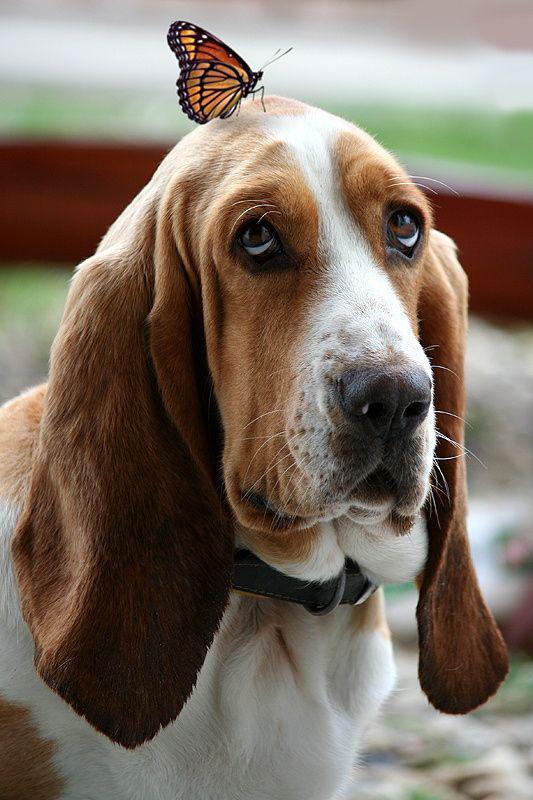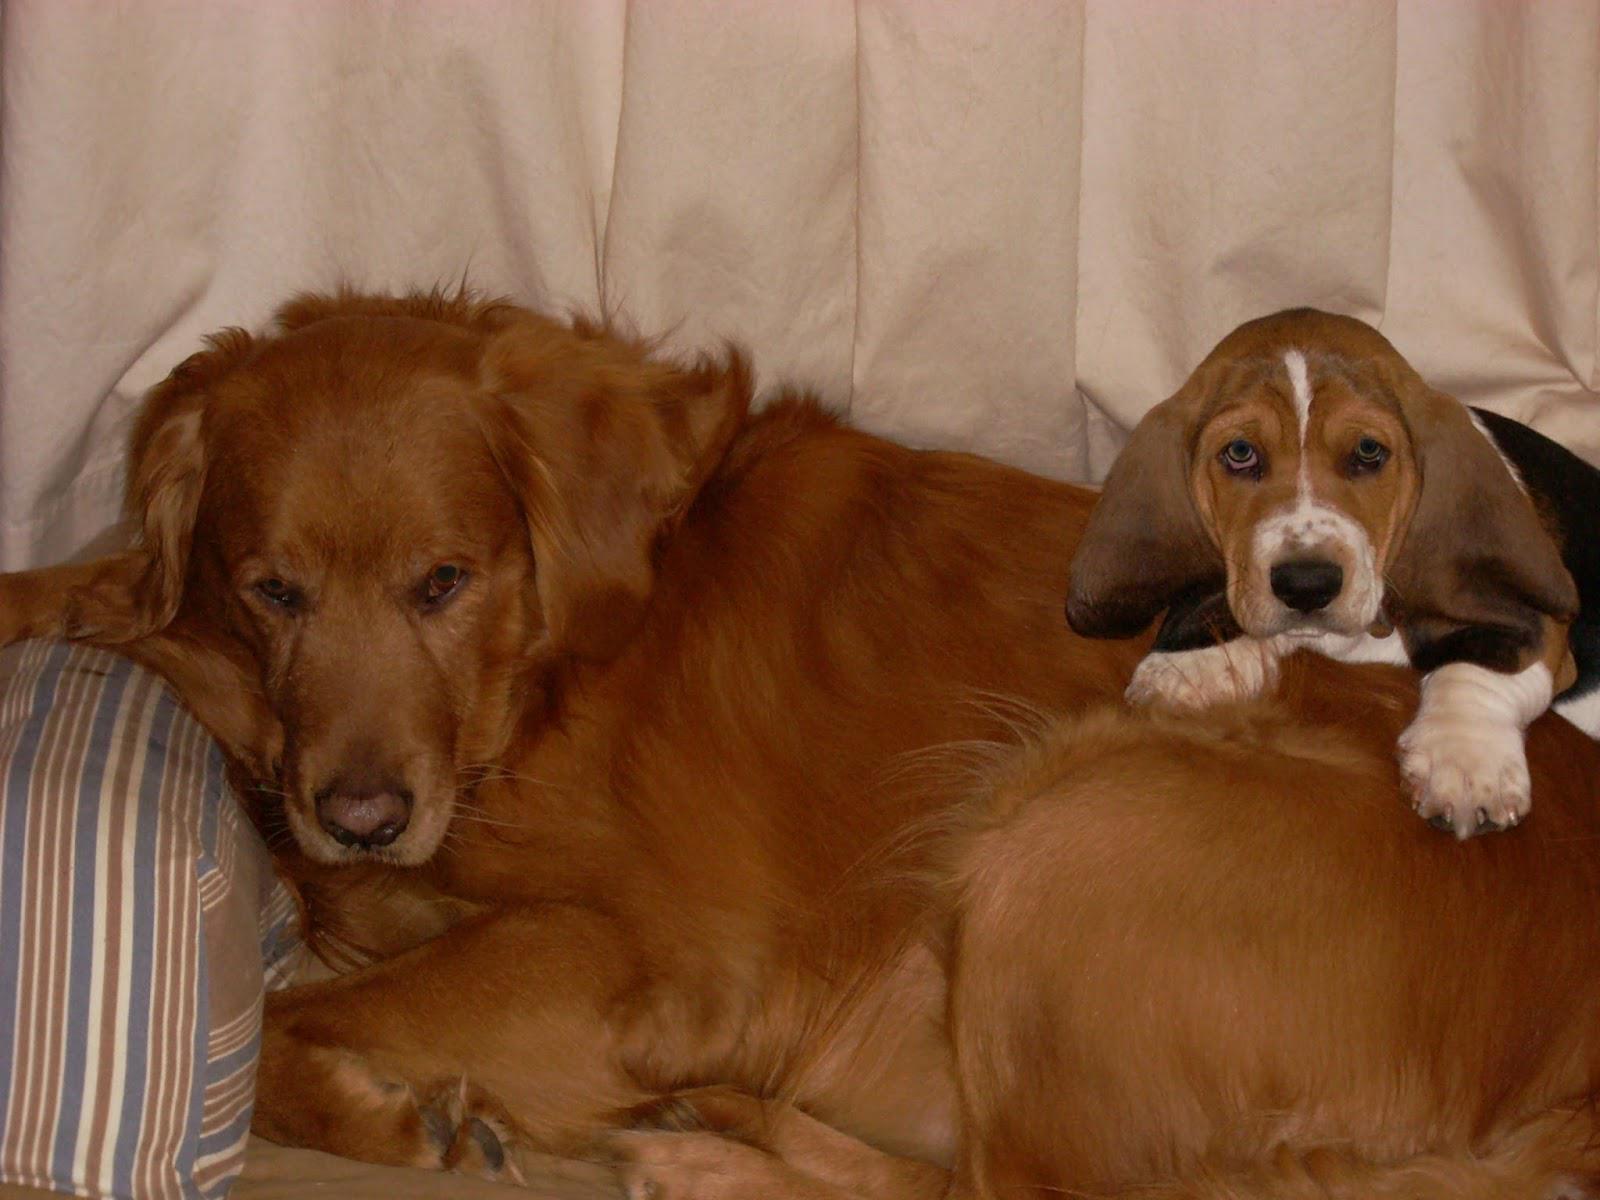The first image is the image on the left, the second image is the image on the right. Considering the images on both sides, is "One image shows a basset hound licking an animal that is not a dog." valid? Answer yes or no. No. 